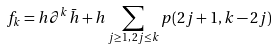<formula> <loc_0><loc_0><loc_500><loc_500>f _ { k } = h \partial ^ { k } \bar { h } + h \sum _ { j \geq 1 , \, 2 j \leq k } p ( 2 j + 1 , k - 2 j )</formula> 